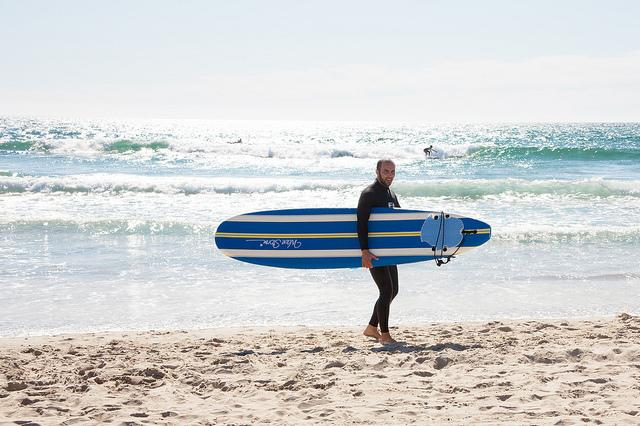What type of outfit is the man wearing? Please explain your reasoning. wet suit. The man is wearing a wetsuit to surf. 